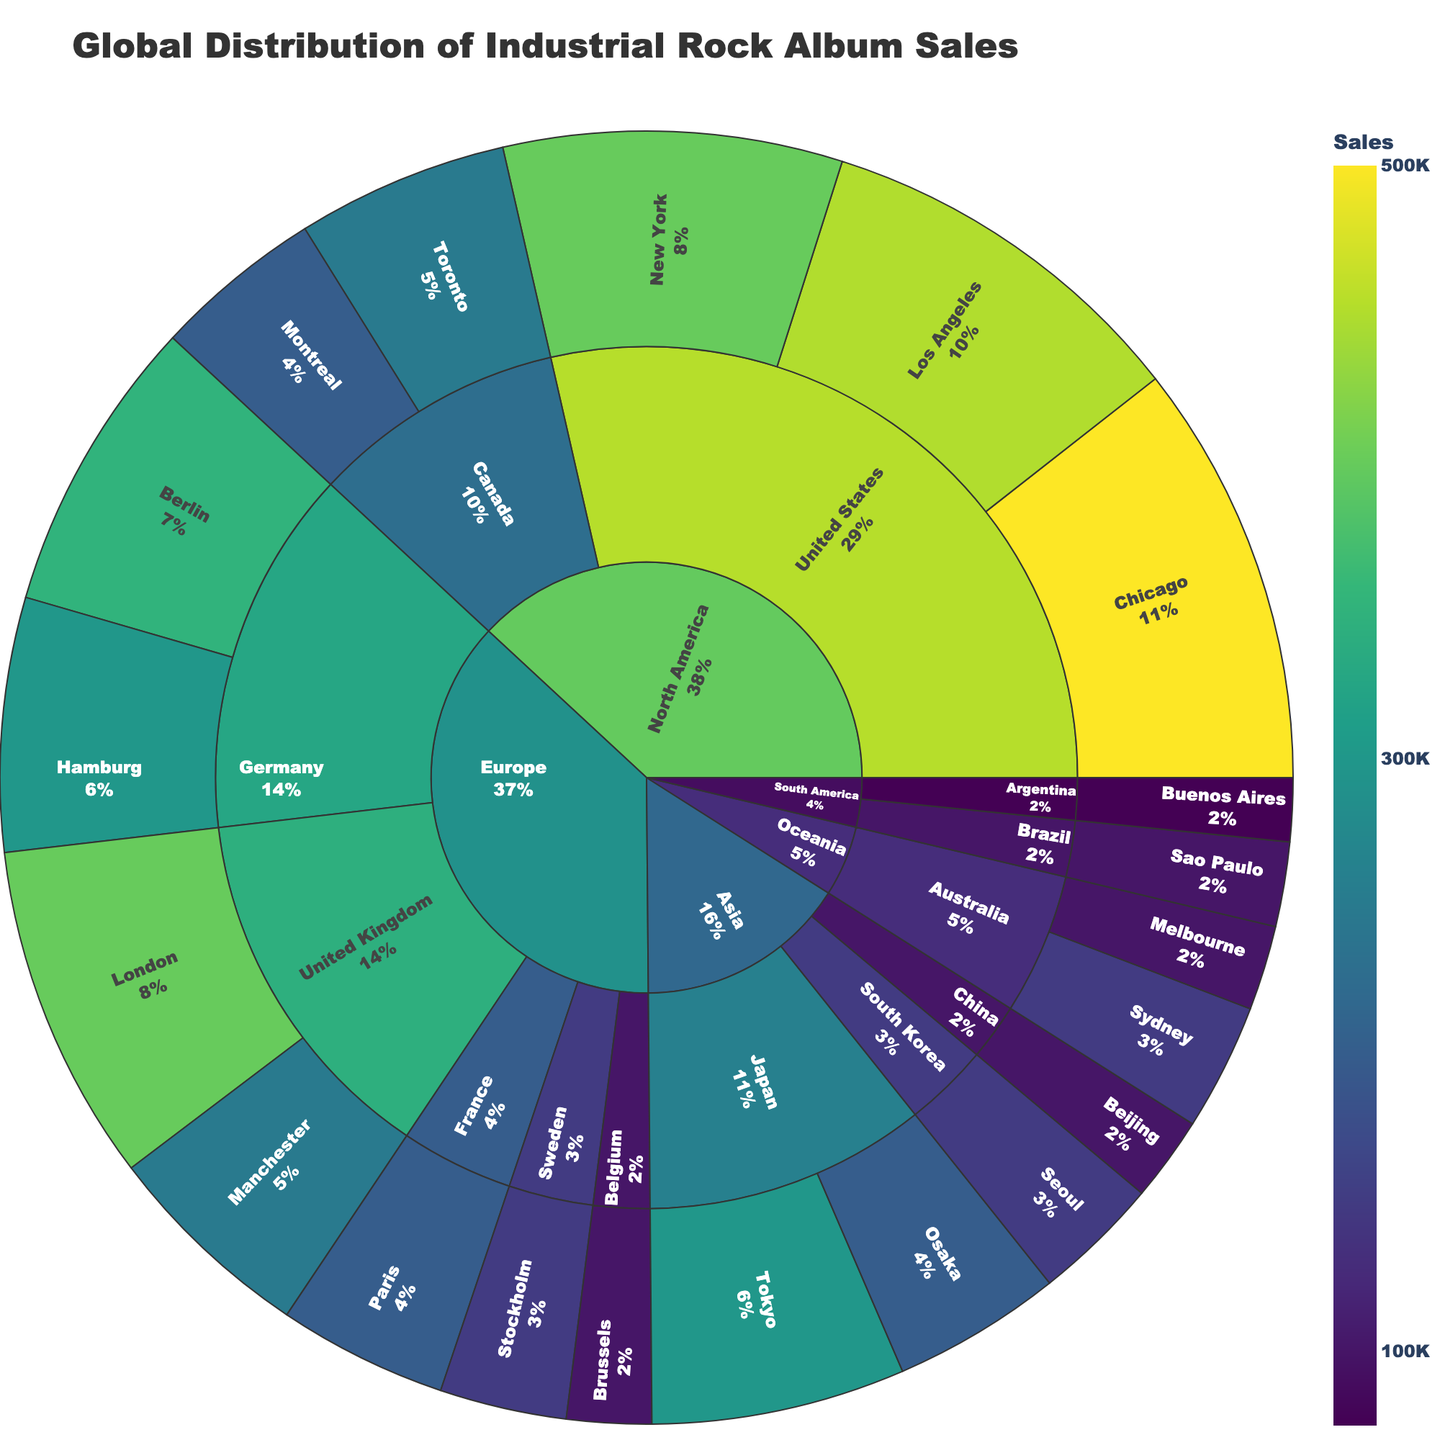Which city in the United States has the highest industrial rock album sales? By looking at the North America region and focusing on the United States, we see that Chicago has the largest segment within the country.
Answer: Chicago Which continent has the least industrial rock album sales overall? The size of the segments for South America is smaller compared to other continents.
Answer: South America How do the album sales in London compare to those in Berlin? Examining the segments in Europe, London has a larger segment than Berlin, indicating higher sales in London.
Answer: London has higher sales What is the total sales amount for industrial rock albums in Canada? Adding the sales in Toronto (250,000) and Montreal (200,000) gives the total sales for Canada. Total = 250,000 + 200,000
Answer: 450,000 Which city in Asia has the highest sales figure for industrial rock albums? By looking at the Asian region, Tokyo is the largest segment, indicating the highest sales.
Answer: Tokyo If you combine the sales of Manchester and Stockholm, what percentage of London's sales would that be? Manchester has 250,000 sales, and Stockholm has 150,000 sales, summing up to 400,000 together. London has 400,000 sales. Therefore, (400,000 / 400,000) * 100% = 100%.
Answer: 100% What is the difference in album sales between Seoul and Sydney? Seoul has 150,000 sales and Sydney has 150,000 sales. The difference is 0 (150,000 - 150,000).
Answer: 0 Which country in South America has higher industrial rock album sales? In South America, Brazil (100,000) has higher sales compared to Argentina (75,000).
Answer: Brazil How do the sales in France compare to those in Belgium? France's Paris has 200,000 sales, whereas Belgium’s Brussels has 100,000 sales. Paris has higher sales.
Answer: Paris has higher sales What is the combined sales of all cities in Germany? Adding sales from Berlin (350,000) and Hamburg (300,000) gives the total for Germany. Total = 350,000 + 300,000
Answer: 650,000 